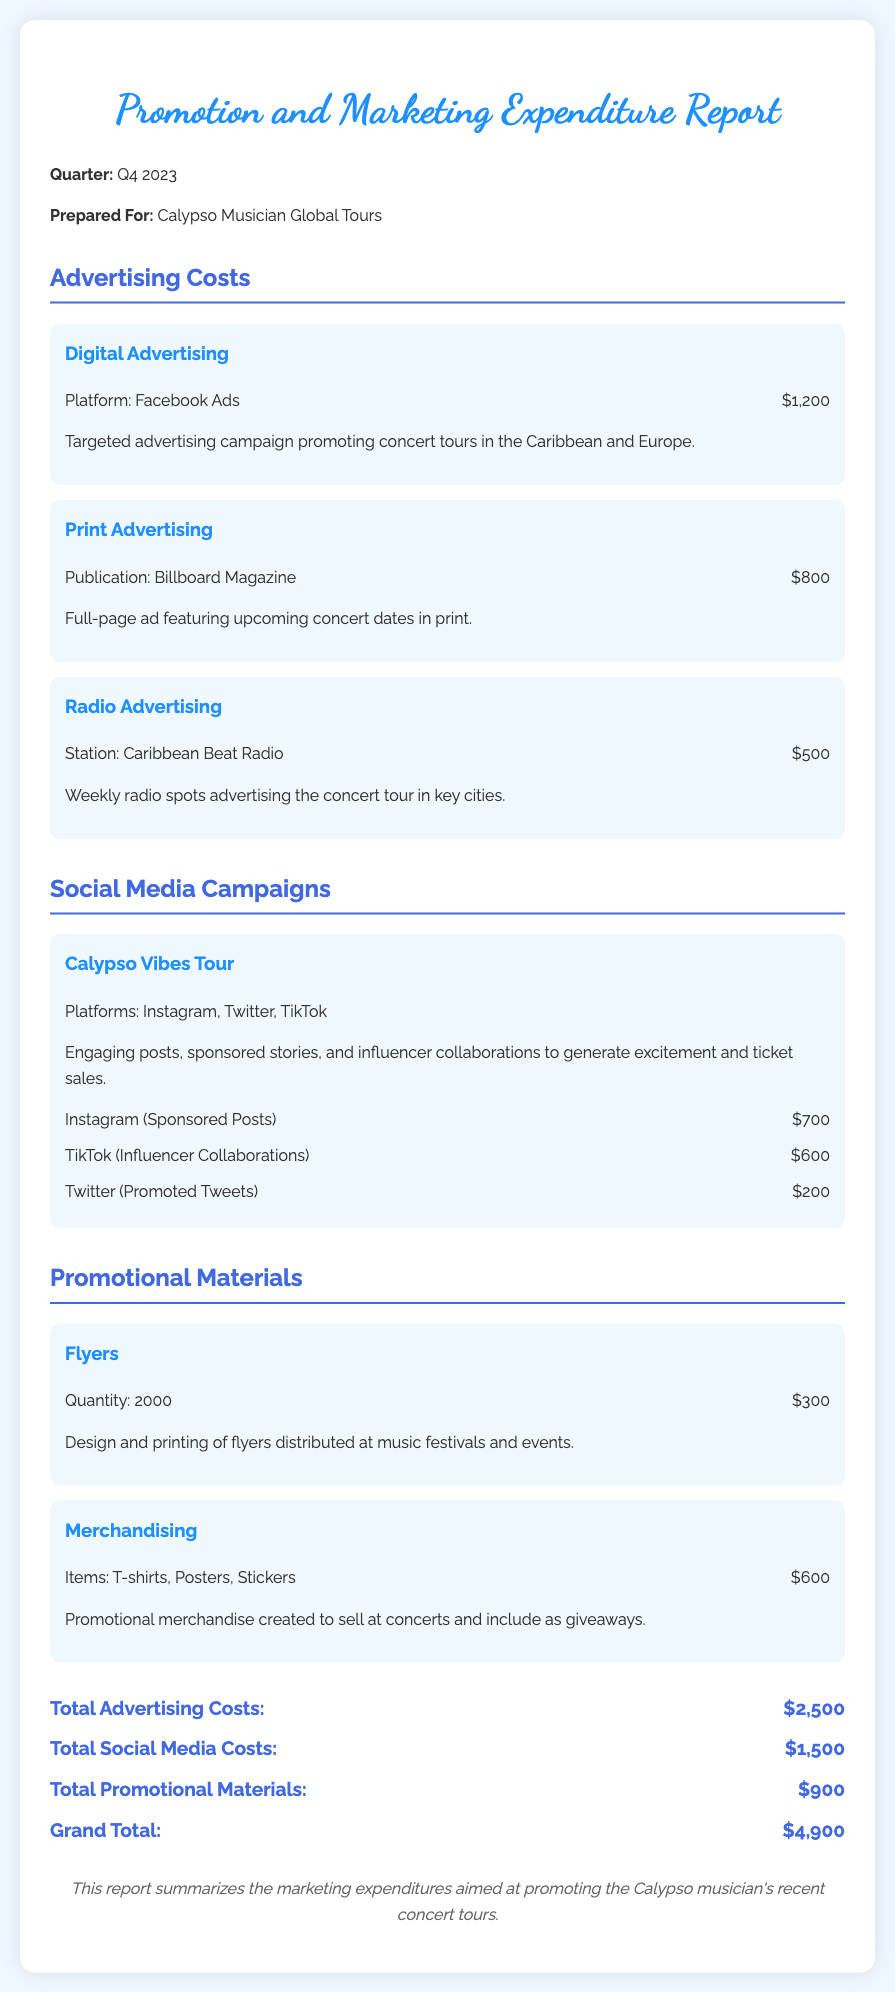What are the total advertising costs? The total advertising costs are specified in the document and are listed as $2,500.
Answer: $2,500 Which social media platform had the highest expenditure? The expenditure for Instagram sponsored posts is the highest among the listed social media campaigns, totaling $700.
Answer: Instagram What is the total cost for promotional materials? The total cost for promotional materials is mentioned in the document and is $900.
Answer: $900 How much was spent on print advertising? The document lists the cost for print advertising in Billboard Magazine as $800.
Answer: $800 What platforms were used for the Calypso Vibes Tour campaign? The platforms used for the Calypso Vibes Tour are detailed in the document as Instagram, Twitter, and TikTok.
Answer: Instagram, Twitter, TikTok What is the grand total of all expenditures? The grand total of all expenditures is provided in the document as $4,900.
Answer: $4,900 What type of promotional materials included T-shirts, Posters, and Stickers? The document refers to these items under the section titled Merchandising.
Answer: Merchandising How many flyers were printed for the promotional campaign? The document indicates that 2000 flyers were printed for distribution.
Answer: 2000 What is the purpose of the radio advertising mentioned? According to the document, the purpose is to advertise the concert tour in key cities.
Answer: To advertise concert tour in key cities 